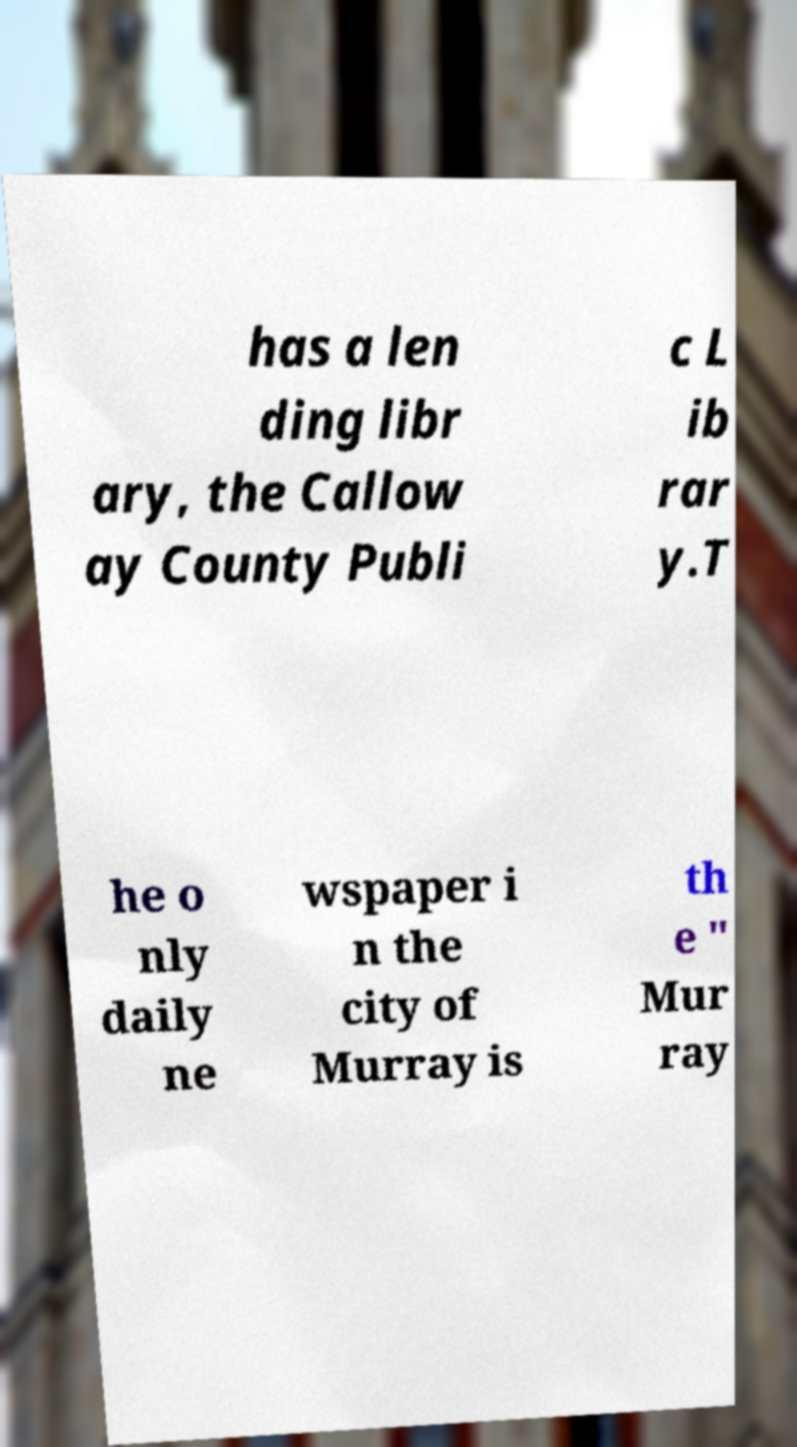There's text embedded in this image that I need extracted. Can you transcribe it verbatim? has a len ding libr ary, the Callow ay County Publi c L ib rar y.T he o nly daily ne wspaper i n the city of Murray is th e " Mur ray 